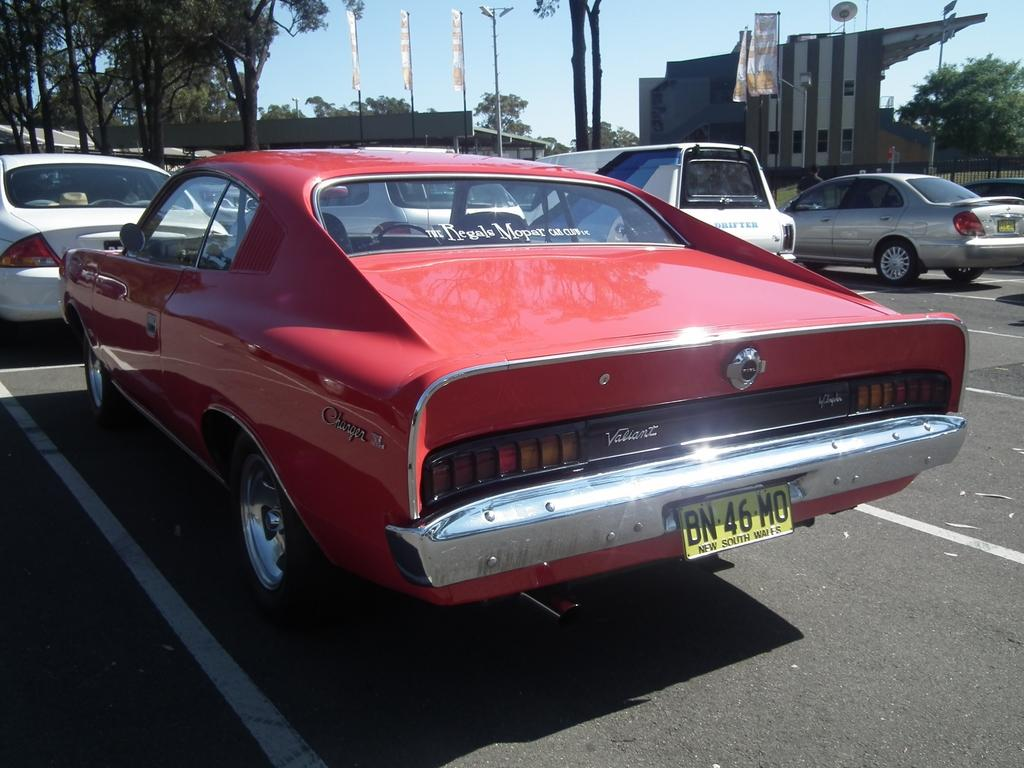<image>
Share a concise interpretation of the image provided. The license plate shows that this car is from New South Wales. 